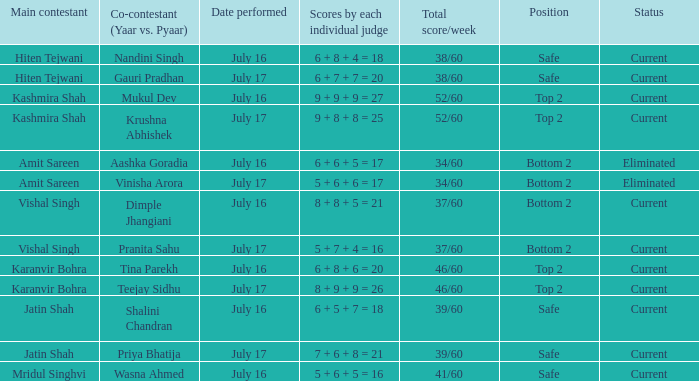What date did Jatin Shah and Shalini Chandran perform? July 16. 